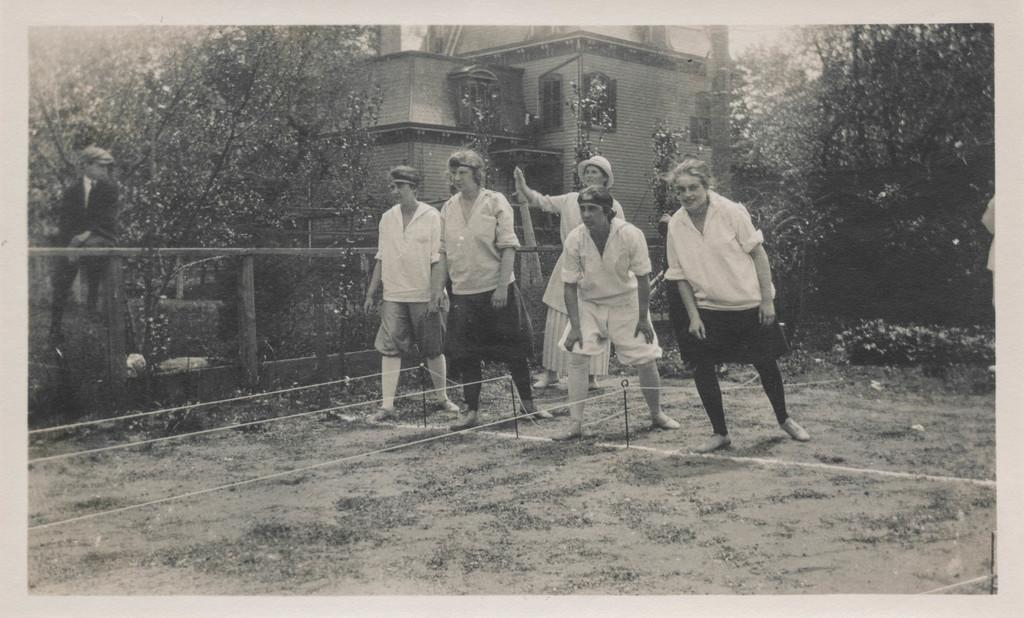What are the people in the image doing? The people in the image are standing. Can you describe the position of the boy in the image? The boy is sitting on the left side of the image. What type of terrain is visible in the image? There is sand visible in the image. What natural elements can be seen in the image? There are trees in the image. What type of structure is present in the image? There is a building in the image. What channel is the boy watching on the left side of the image? There is no television or channel present in the image; the boy is sitting on the sand. 